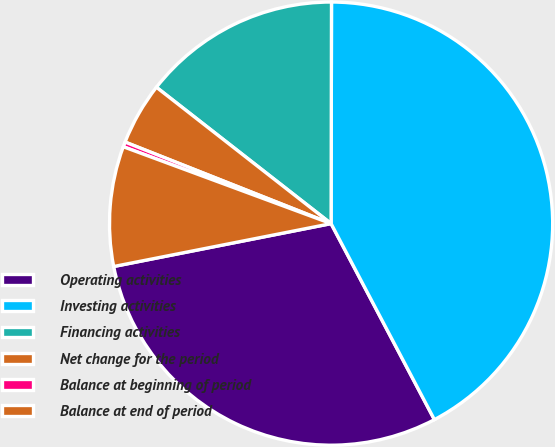Convert chart. <chart><loc_0><loc_0><loc_500><loc_500><pie_chart><fcel>Operating activities<fcel>Investing activities<fcel>Financing activities<fcel>Net change for the period<fcel>Balance at beginning of period<fcel>Balance at end of period<nl><fcel>29.62%<fcel>42.25%<fcel>14.48%<fcel>4.55%<fcel>0.36%<fcel>8.74%<nl></chart> 